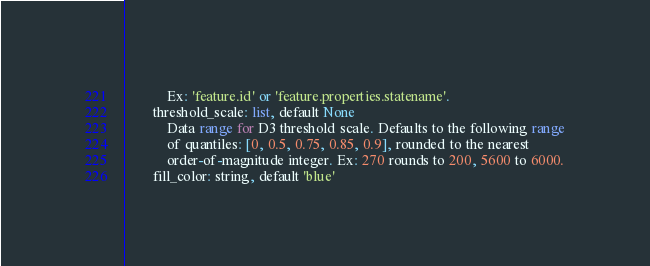<code> <loc_0><loc_0><loc_500><loc_500><_Python_>            Ex: 'feature.id' or 'feature.properties.statename'.
        threshold_scale: list, default None
            Data range for D3 threshold scale. Defaults to the following range
            of quantiles: [0, 0.5, 0.75, 0.85, 0.9], rounded to the nearest
            order-of-magnitude integer. Ex: 270 rounds to 200, 5600 to 6000.
        fill_color: string, default 'blue'</code> 